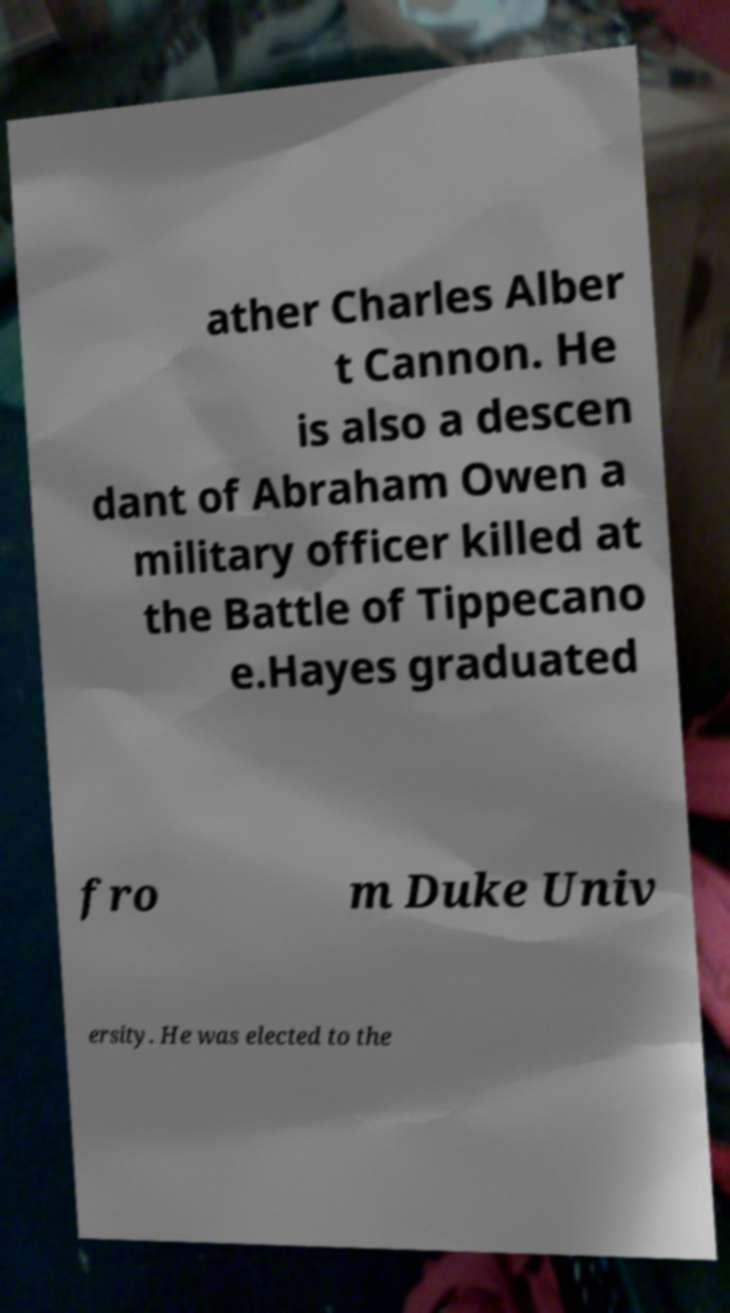Can you read and provide the text displayed in the image?This photo seems to have some interesting text. Can you extract and type it out for me? ather Charles Alber t Cannon. He is also a descen dant of Abraham Owen a military officer killed at the Battle of Tippecano e.Hayes graduated fro m Duke Univ ersity. He was elected to the 